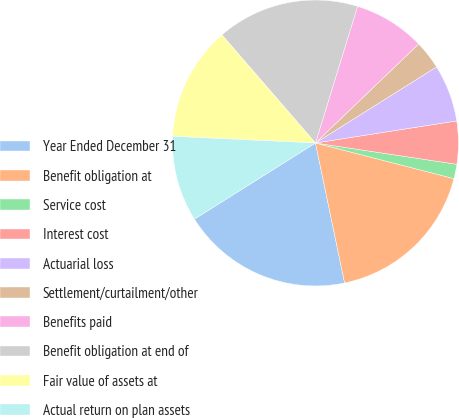Convert chart to OTSL. <chart><loc_0><loc_0><loc_500><loc_500><pie_chart><fcel>Year Ended December 31<fcel>Benefit obligation at<fcel>Service cost<fcel>Interest cost<fcel>Actuarial loss<fcel>Settlement/curtailment/other<fcel>Benefits paid<fcel>Benefit obligation at end of<fcel>Fair value of assets at<fcel>Actual return on plan assets<nl><fcel>19.33%<fcel>17.72%<fcel>1.63%<fcel>4.85%<fcel>6.46%<fcel>3.24%<fcel>8.07%<fcel>16.11%<fcel>12.9%<fcel>9.68%<nl></chart> 